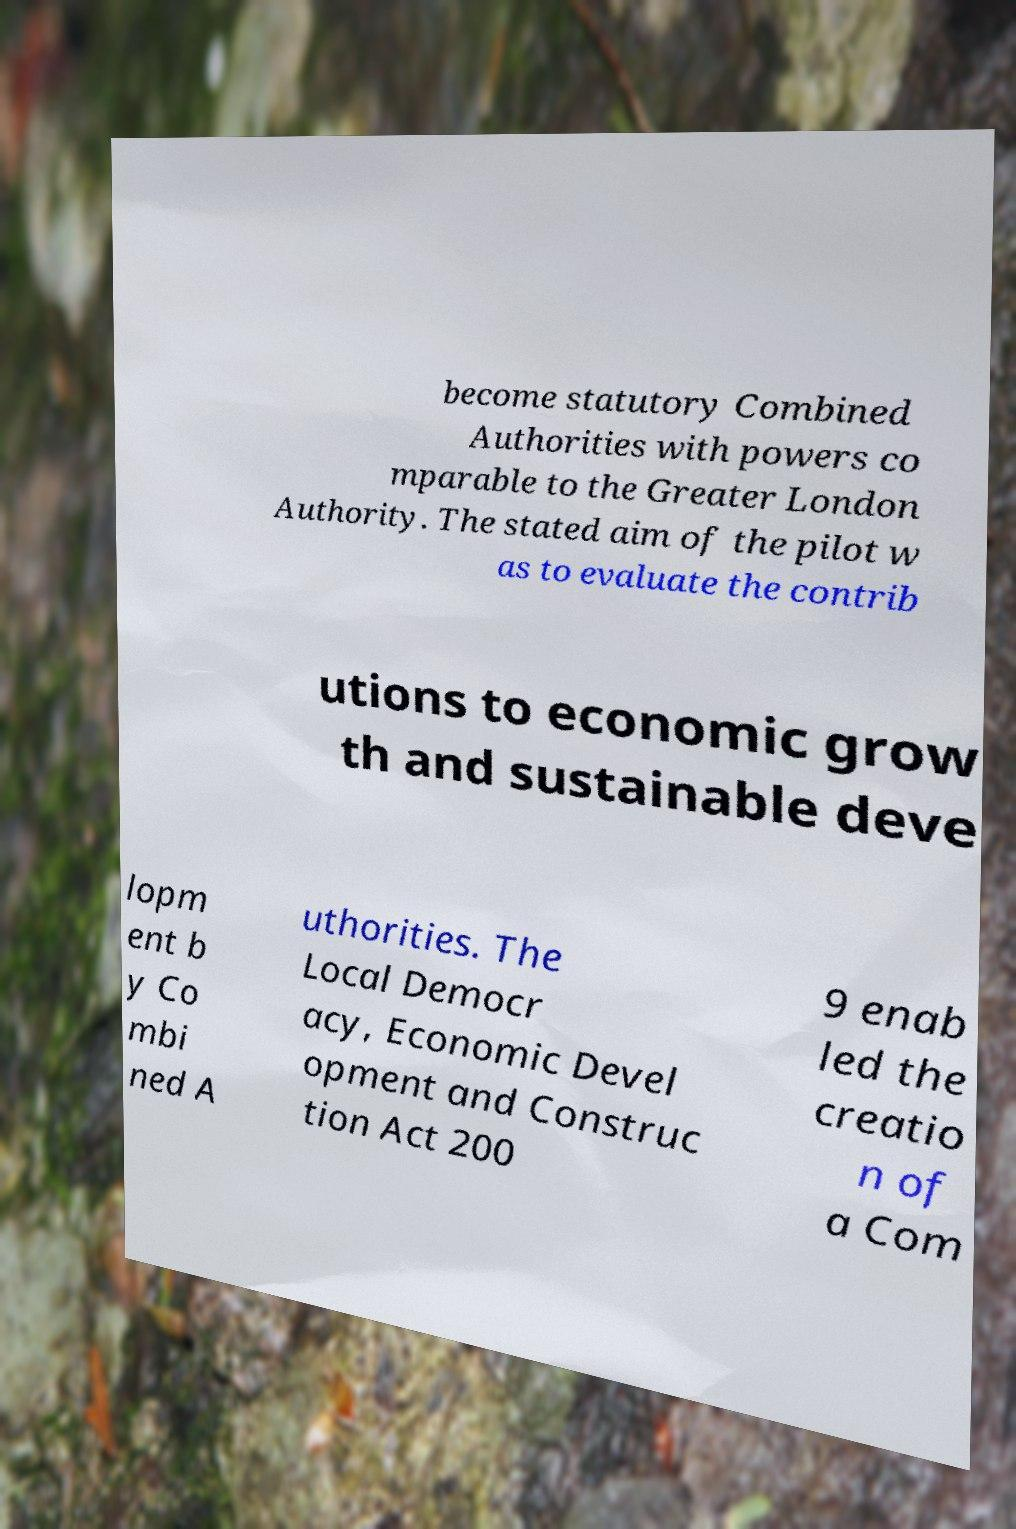Could you assist in decoding the text presented in this image and type it out clearly? become statutory Combined Authorities with powers co mparable to the Greater London Authority. The stated aim of the pilot w as to evaluate the contrib utions to economic grow th and sustainable deve lopm ent b y Co mbi ned A uthorities. The Local Democr acy, Economic Devel opment and Construc tion Act 200 9 enab led the creatio n of a Com 